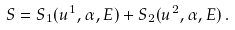Convert formula to latex. <formula><loc_0><loc_0><loc_500><loc_500>S = S _ { 1 } ( u ^ { 1 } , \alpha , E ) + S _ { 2 } ( u ^ { 2 } , \alpha , E ) \, .</formula> 